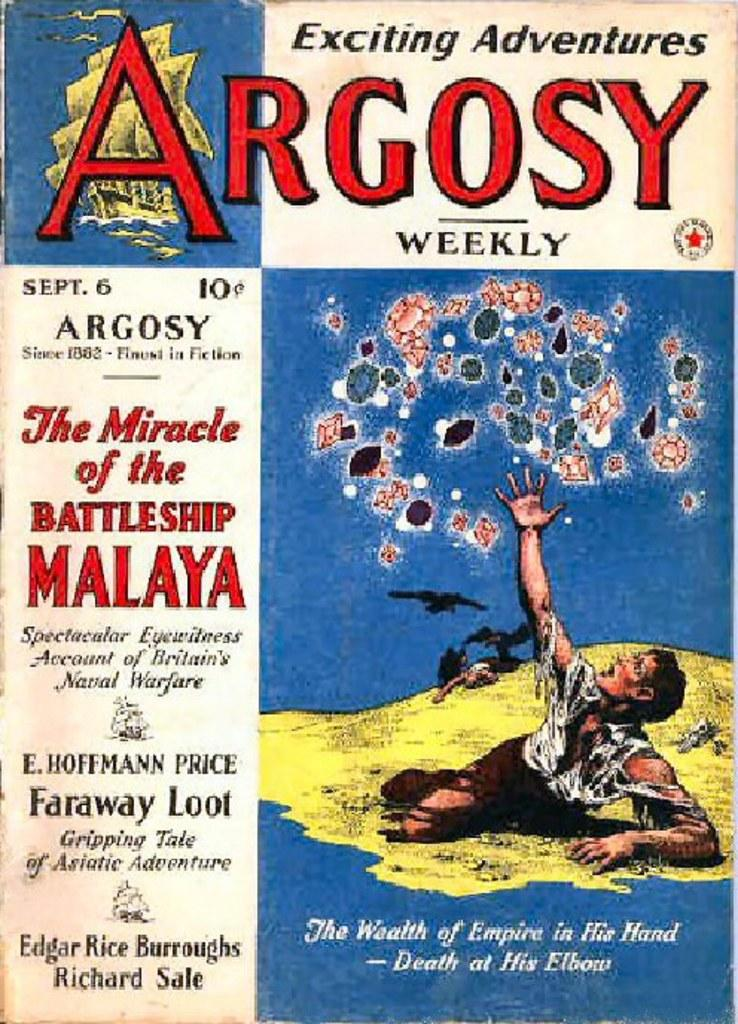<image>
Present a compact description of the photo's key features. a book with the word Argosy at the top 